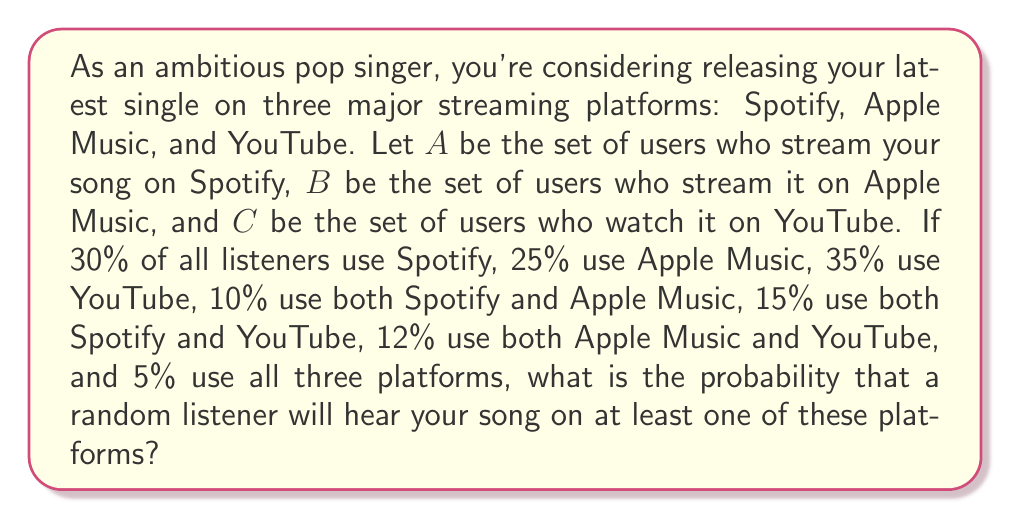Could you help me with this problem? To solve this problem, we'll use the inclusion-exclusion principle from set theory. Let's break it down step by step:

1) First, let's define our universe U as all potential listeners, and |U| = 100% (total probability).

2) Given:
   P(A) = 30% = 0.30
   P(B) = 25% = 0.25
   P(C) = 35% = 0.35
   P(A ∩ B) = 10% = 0.10
   P(A ∩ C) = 15% = 0.15
   P(B ∩ C) = 12% = 0.12
   P(A ∩ B ∩ C) = 5% = 0.05

3) We want to find P(A ∪ B ∪ C), which represents the probability of a listener using at least one platform.

4) The inclusion-exclusion principle for three sets states:

   $$P(A ∪ B ∪ C) = P(A) + P(B) + P(C) - P(A ∩ B) - P(A ∩ C) - P(B ∩ C) + P(A ∩ B ∩ C)$$

5) Let's substitute our values:

   $$P(A ∪ B ∪ C) = 0.30 + 0.25 + 0.35 - 0.10 - 0.15 - 0.12 + 0.05$$

6) Calculate:

   $$P(A ∪ B ∪ C) = 0.90 - 0.37 + 0.05 = 0.58$$

Therefore, the probability that a random listener will hear your song on at least one of these platforms is 0.58 or 58%.
Answer: 0.58 or 58% 